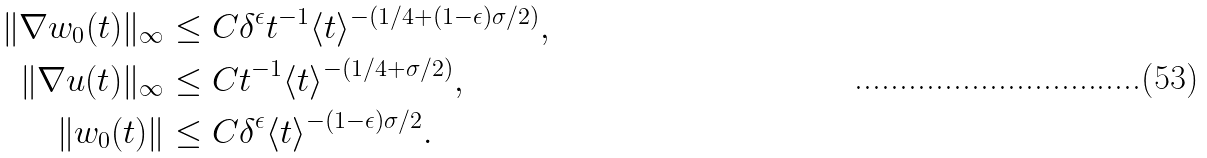Convert formula to latex. <formula><loc_0><loc_0><loc_500><loc_500>\| \nabla w _ { 0 } ( t ) \| _ { \infty } & \leq C \delta ^ { \epsilon } t ^ { - 1 } \langle t \rangle ^ { - ( 1 / 4 + ( 1 - \epsilon ) \sigma / 2 ) } , \\ \| \nabla u ( t ) \| _ { \infty } & \leq C t ^ { - 1 } \langle t \rangle ^ { - ( 1 / 4 + \sigma / 2 ) } , \\ \| w _ { 0 } ( t ) \| & \leq C \delta ^ { \epsilon } \langle t \rangle ^ { - ( 1 - \epsilon ) \sigma / 2 } .</formula> 